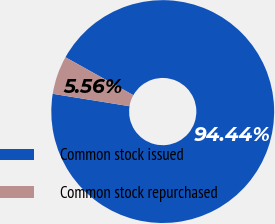Convert chart to OTSL. <chart><loc_0><loc_0><loc_500><loc_500><pie_chart><fcel>Common stock issued<fcel>Common stock repurchased<nl><fcel>94.44%<fcel>5.56%<nl></chart> 